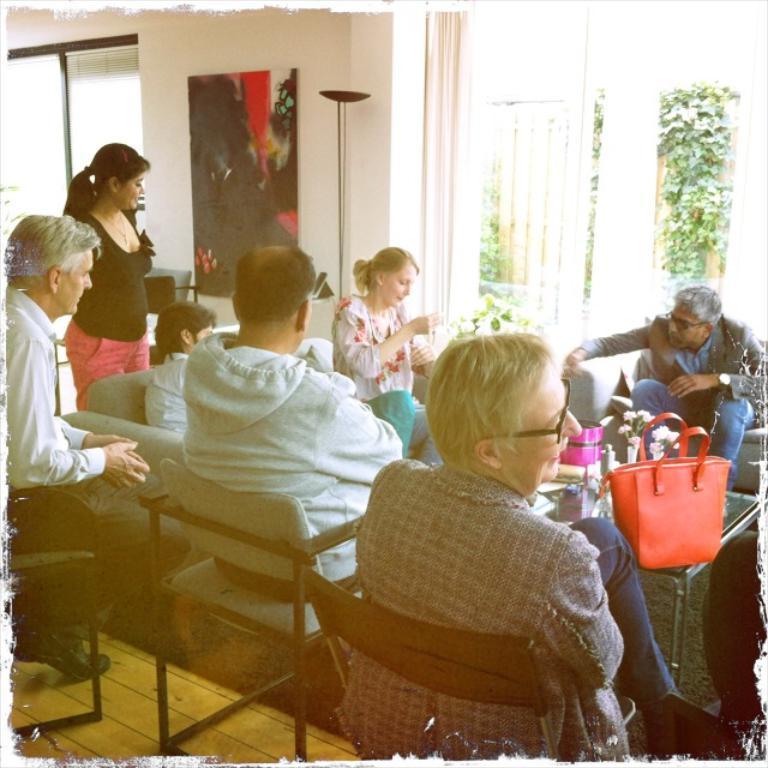In one or two sentences, can you explain what this image depicts? This picture describes about group of people few are seated on the chair and few are standing, in front of them we can see a bag, flower vase on the table, and also we can find wall painting, curtains, and couple of plants. 